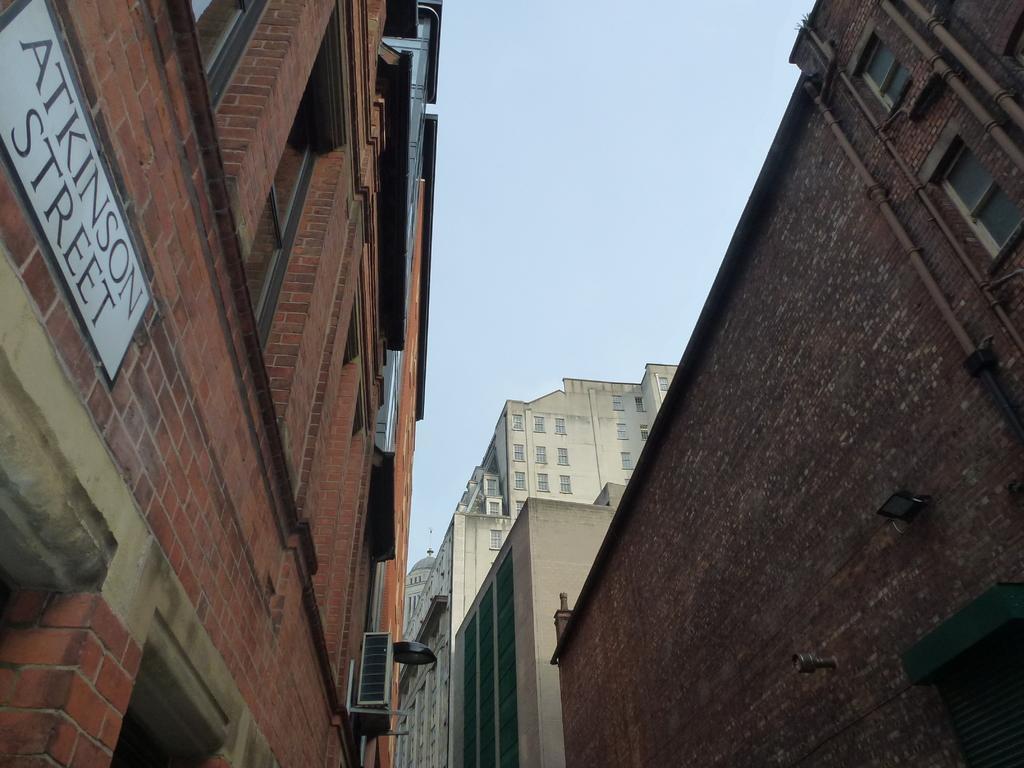How would you summarize this image in a sentence or two? In this picture we can see there are buildings with windows, a name board and an object. Behind the buildings there is the sky. 